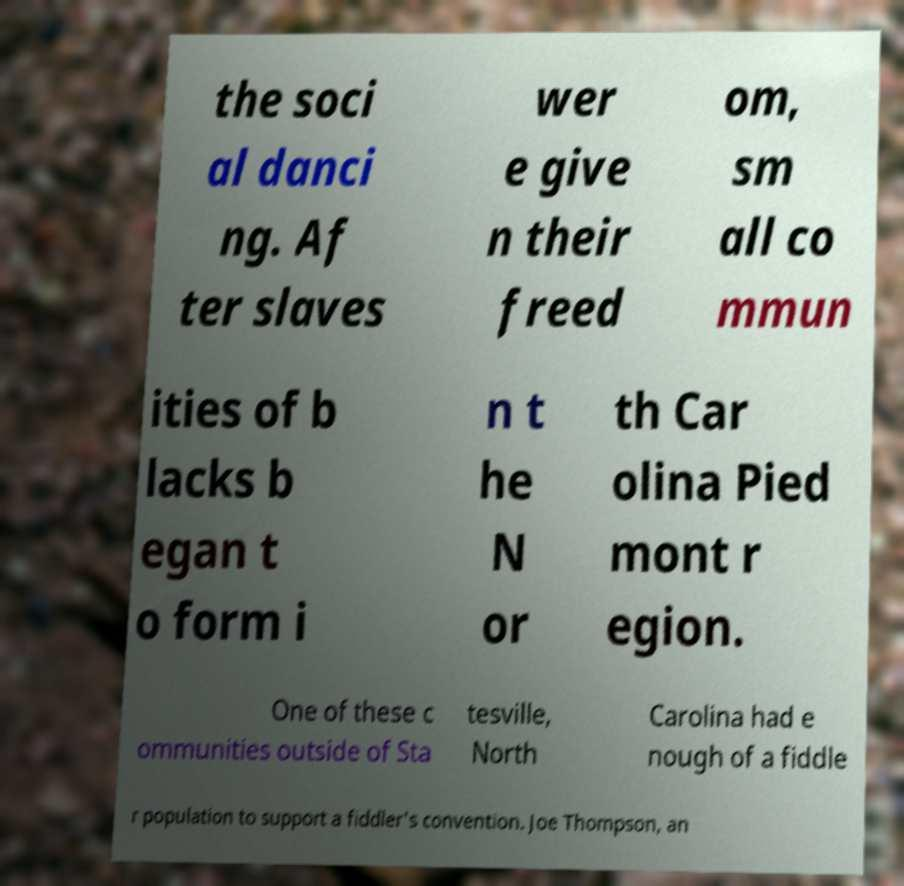For documentation purposes, I need the text within this image transcribed. Could you provide that? the soci al danci ng. Af ter slaves wer e give n their freed om, sm all co mmun ities of b lacks b egan t o form i n t he N or th Car olina Pied mont r egion. One of these c ommunities outside of Sta tesville, North Carolina had e nough of a fiddle r population to support a fiddler's convention. Joe Thompson, an 